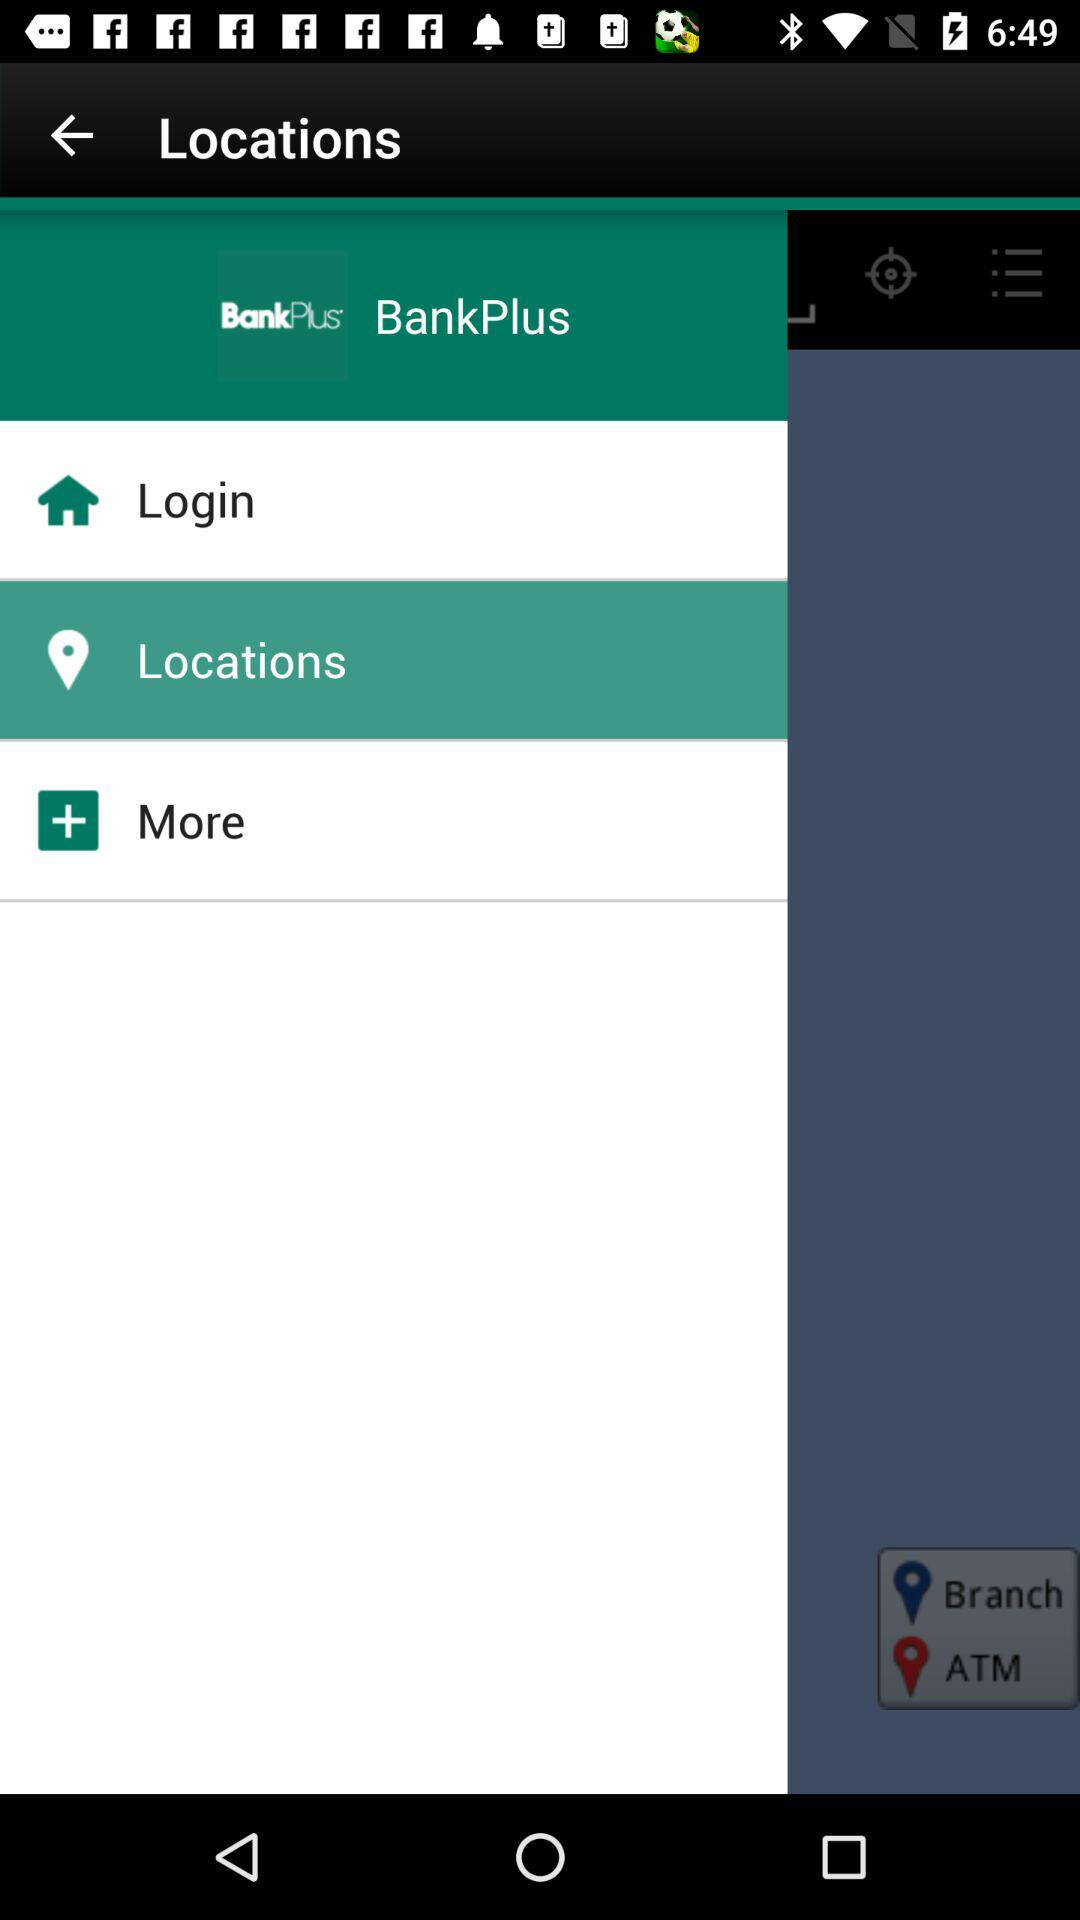What is the name of the application? The name of the application is "BankPlus". 